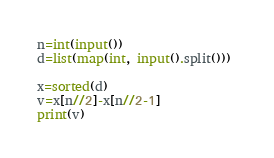<code> <loc_0><loc_0><loc_500><loc_500><_Python_>n=int(input())
d=list(map(int, input().split())) 

x=sorted(d)
v=x[n//2]-x[n//2-1]
print(v)
</code> 